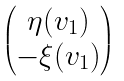Convert formula to latex. <formula><loc_0><loc_0><loc_500><loc_500>\begin{pmatrix} \eta ( v _ { 1 } ) \\ - \xi ( v _ { 1 } ) \end{pmatrix}</formula> 